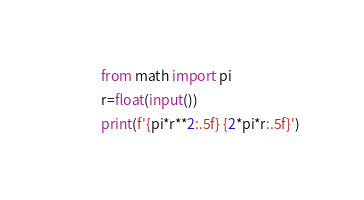Convert code to text. <code><loc_0><loc_0><loc_500><loc_500><_Python_>from math import pi
r=float(input())
print(f'{pi*r**2:.5f} {2*pi*r:.5f}')

</code> 